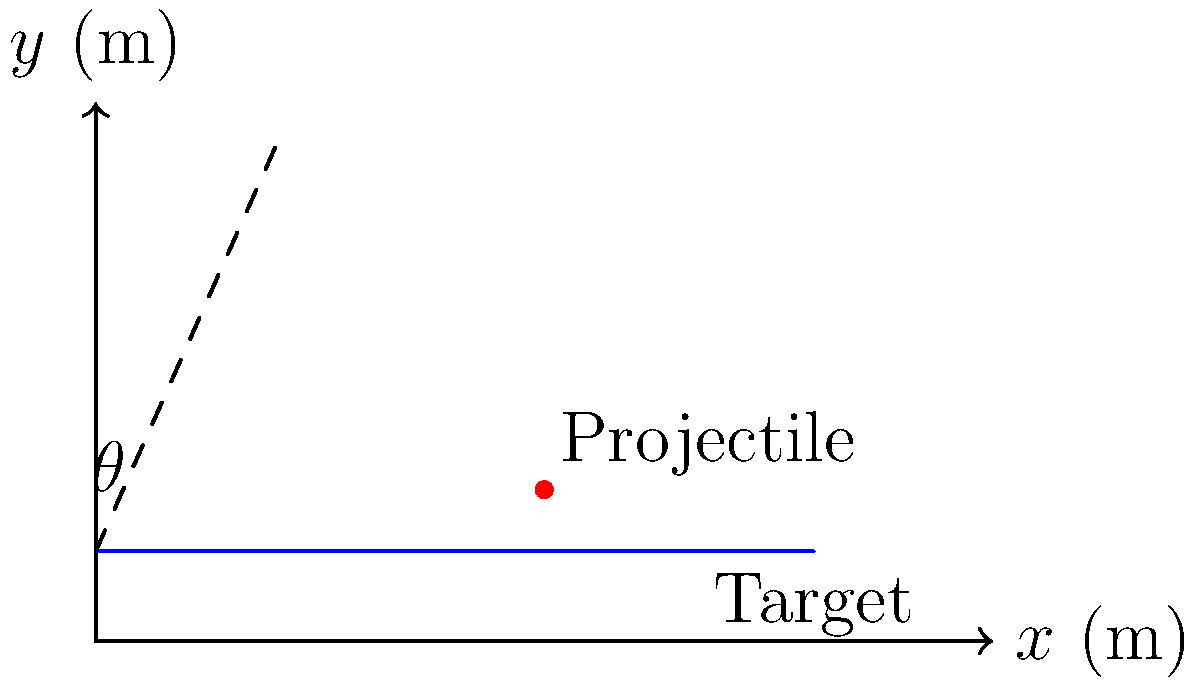As a skilled operative, you need to neutralize a moving target with a precision-launched projectile. The target is moving along a straight path 10 meters above the ground, starting at a distance of 80 meters from your position. Your launch point is at ground level. The projectile's initial velocity is 50 m/s, and the target is moving at a constant speed of 5 m/s towards you. Calculate the optimal launch angle $\theta$ to hit the target, assuming negligible air resistance and using $g = 9.8$ m/s². To solve this problem, we'll use the equations of motion for projectile motion and the target's linear motion. Let's approach this step-by-step:

1) First, we need to determine when and where the projectile and target will meet. Let's call this time $t$.

2) The target's position at time $t$ will be:
   $x_target = 80 - 5t$ (moving towards us)
   $y_target = 10$ (constant height)

3) The projectile's position at time $t$ will be:
   $x_projectile = (50 \cos\theta)t$
   $y_projectile = (50 \sin\theta)t - \frac{1}{2}gt^2$

4) For a hit, these positions must be equal:
   $80 - 5t = (50 \cos\theta)t$
   $10 = (50 \sin\theta)t - \frac{1}{2}(9.8)t^2$

5) From the first equation:
   $t = \frac{80}{50\cos\theta + 5}$

6) Substituting this into the second equation:
   $10 = (50 \sin\theta)(\frac{80}{50\cos\theta + 5}) - \frac{1}{2}(9.8)(\frac{80}{50\cos\theta + 5})^2$

7) This equation can be solved numerically for $\theta$. Using a numerical solver, we find:
   $\theta \approx 0.2967$ radians or $17.0°$

8) To verify, we can calculate the time of impact:
   $t = \frac{80}{50\cos(17.0°) + 5} \approx 1.60$ seconds

9) At this time:
   Target position: $(80 - 5(1.60), 10) = (72.0, 10)$ meters
   Projectile position: $(50\cos(17.0°)(1.60), 50\sin(17.0°)(1.60) - \frac{1}{2}(9.8)(1.60)^2) \approx (72.0, 10)$ meters

The positions match, confirming our solution.
Answer: $17.0°$ 